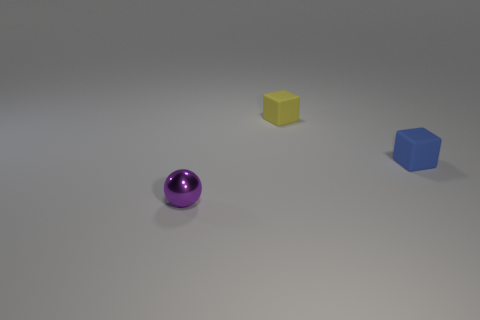Add 3 tiny cyan matte things. How many objects exist? 6 Subtract all balls. How many objects are left? 2 Add 3 tiny purple balls. How many tiny purple balls exist? 4 Subtract 0 red cubes. How many objects are left? 3 Subtract all tiny yellow objects. Subtract all small yellow matte blocks. How many objects are left? 1 Add 3 blue matte things. How many blue matte things are left? 4 